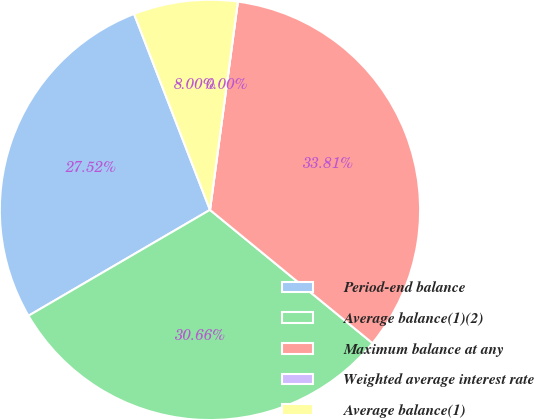Convert chart. <chart><loc_0><loc_0><loc_500><loc_500><pie_chart><fcel>Period-end balance<fcel>Average balance(1)(2)<fcel>Maximum balance at any<fcel>Weighted average interest rate<fcel>Average balance(1)<nl><fcel>27.52%<fcel>30.66%<fcel>33.81%<fcel>0.0%<fcel>8.0%<nl></chart> 